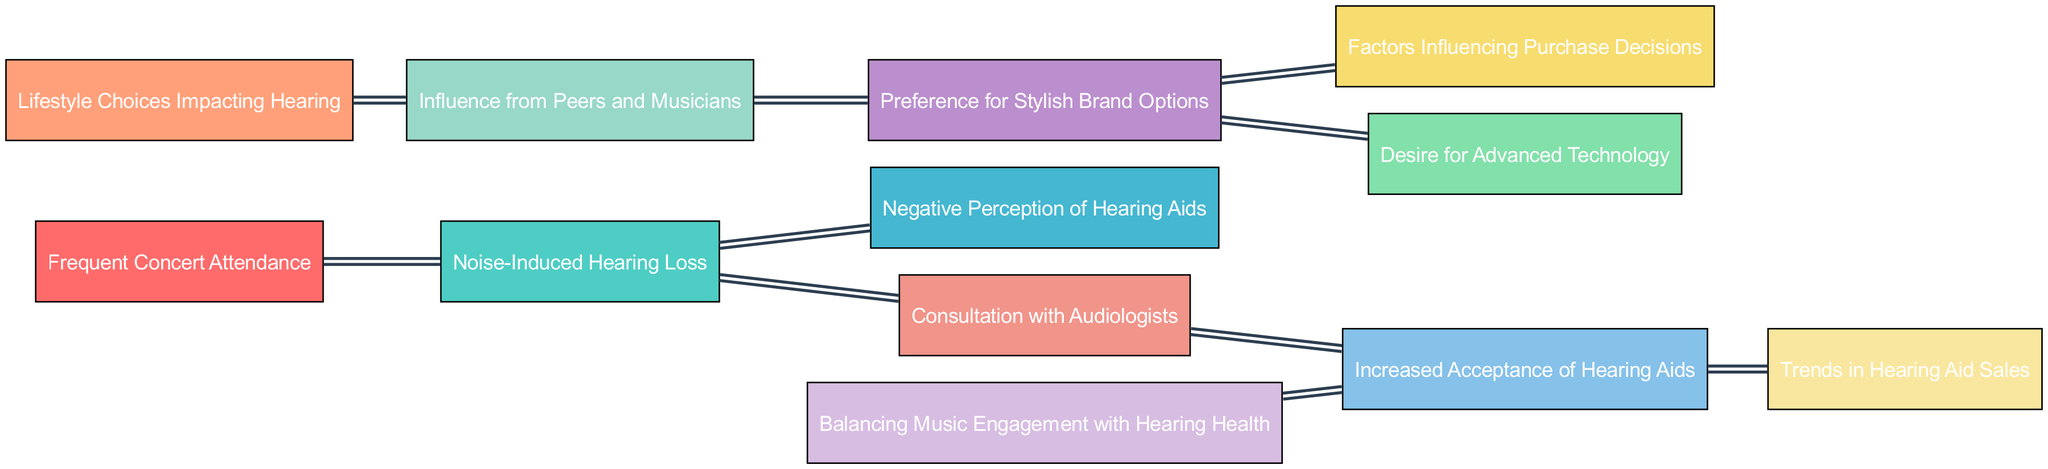What is the total number of nodes in the diagram? The diagram lists 12 unique nodes related to trends in hearing aid usage influenced by lifestyle choices. To find the total, I simply counted each distinct node.
Answer: 12 Which node directly influences 'Noise-Induced Hearing Loss'? The only node that directly influences 'Noise-Induced Hearing Loss' is 'Frequent Concert Attendance', as indicated by the single directing edge connecting these two nodes.
Answer: Frequent Concert Attendance How many links connect 'Brand Preferences' to other nodes? 'Brand Preferences' has two outgoing links, leading to 'Purchase Decision Factors' and 'Technology Integration', which I counted through the connections of the node.
Answer: 2 What is the relationship between 'Hearing Aid Acceptance' and 'Market Trends'? 'Hearing Aid Acceptance' influences 'Market Trends' as shown by a direct edge going from 'Hearing Aid Acceptance' to 'Market Trends', indicating that acceptance of hearing aids impacts market trends.
Answer: Influences Which lifestyle choice directly impacts 'Social Influence'? The node 'Lifestyle Choices' is the one that directly impacts 'Social Influence', as shown by the direct link from 'Lifestyle Choices' to 'Social Influence' in the diagram.
Answer: Lifestyle Choices What is the impact of 'Music Engagement' on 'Hearing Aid Acceptance'? The edge from 'Music Engagement' to 'Hearing Aid Acceptance' suggests that engagement with music has a positive effect on the acceptance of hearing aids, indicating that those engaged with music are more likely to accept hearing aids.
Answer: Positive effect Which node has no outgoing links? Looking at all the nodes, 'Negative Perception of Hearing Aids' does not connect to any other nodes; hence it has no outgoing links.
Answer: Negative Perception of Hearing Aids What factors may influence purchase decisions according to the diagram? The factors influencing purchase decisions are derived from links emanating from 'Brand Preferences', suggesting it leads to 'Purchase Decision Factors' and 'Technology Integration', making them the key influences on decisions.
Answer: Brand Preferences, Technology Integration How does 'Healthcare Consultation' relate to 'Hearing Aid Acceptance'? 'Healthcare Consultation' leads to 'Hearing Aid Acceptance' via a direct link, indicating that consulting with healthcare professionals has a significant impact on the acceptance of hearing aids.
Answer: Direct link 